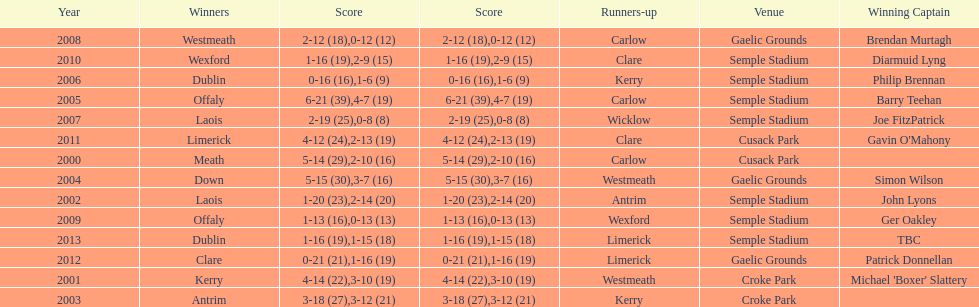Which team was the first to win with a team captain? Kerry. 